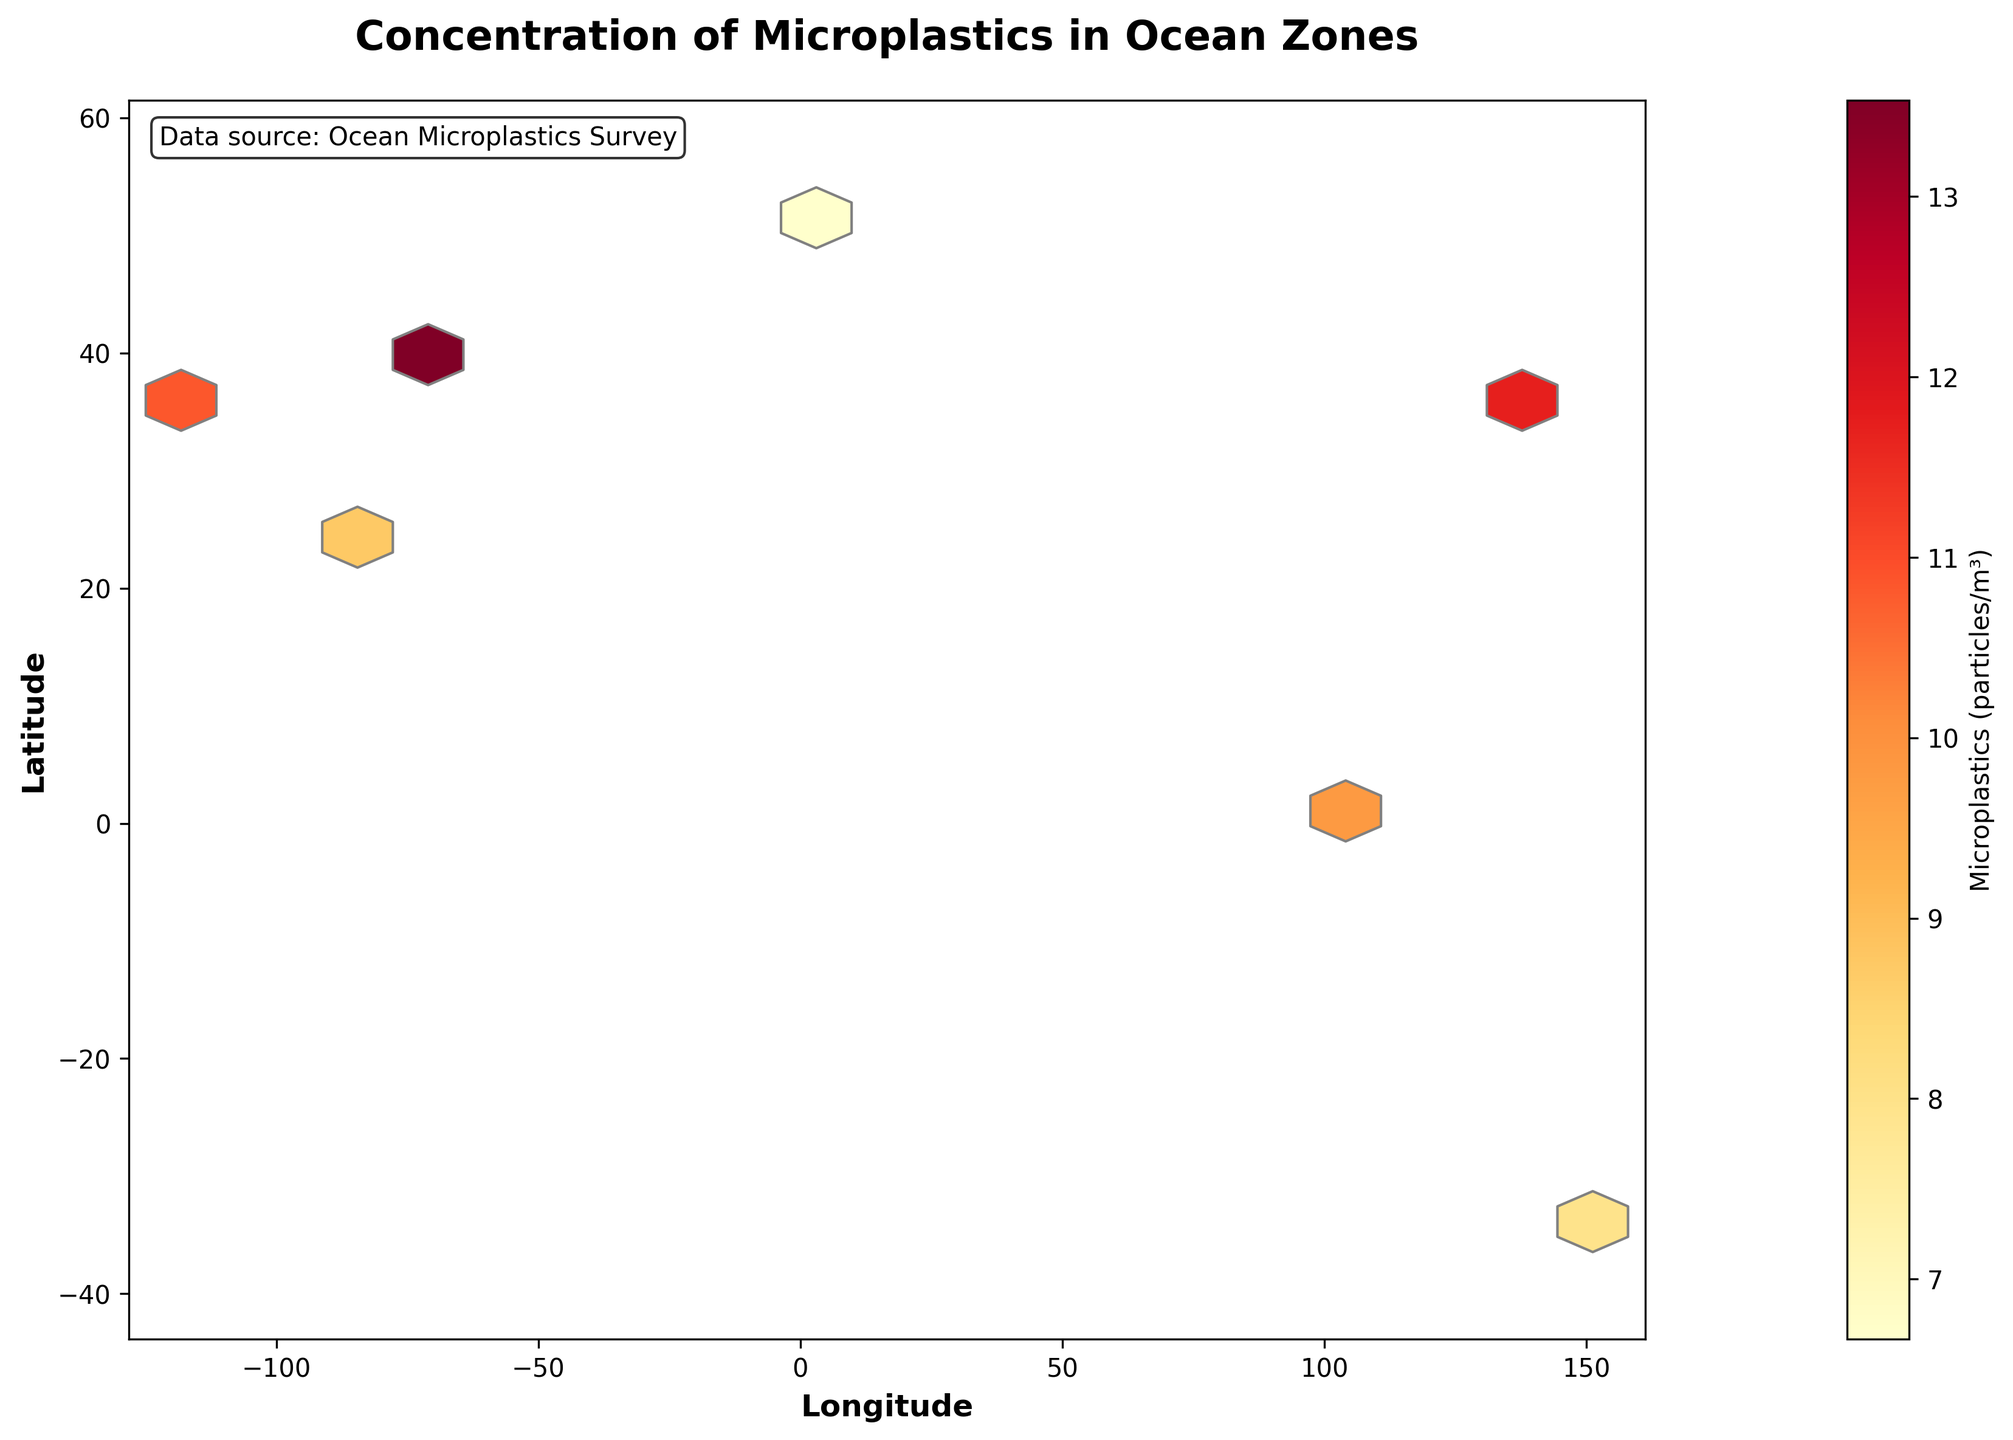What is the title of the figure? The title of the figure is located at the top of the plot. From the visual, we can see the text that describes what the plot represents.
Answer: Concentration of Microplastics in Ocean Zones What do the labels on the x-axis and y-axis represent? The labels on the axes provide contextual information about what is being plotted on each axis. By looking at the plot, we can see the text next to the axes.
Answer: Longitude, Latitude What color indicates the highest concentration of microplastics? The colors in the hexbin plot represent different concentrations of microplastics, with a colorbar legend to aid interpretation. The highest concentration is represented by the color indicated at the upper end of the color gradient on the colorbar.
Answer: Dark Red How do microplastic concentrations vary with depth in the ocean zones? Since depth data is not explicitly plotted but the figure represents averaged or cumulative concentrations, we need to compare the values at different coordinates to sense trends. Generally, higher concentrations at surface vs. depths shown by lower plotted values at deeper coordinates.
Answer: Higher at the surface, lower at deeper depths Which region shows the highest concentration of microplastics? By examining the denser hexagons and referring to the color that represents higher values on the colorbar, the region exhibiting this color indicates the highest concentration.
Answer: Around 40.7128,-74.0060 (New York) Is there any significant difference in microplastic concentration between the Northern and Southern Hemispheres? We compare the density and color of hexagons above and below the equator (0° latitude). Visual inspection of the color intensity indicates concentration differences.
Answer: Yes, higher in the Northern Hemisphere What is the approximate concentration value indicated by the light yellow color in the color gradient? The light yellow color on the colorbar corresponds to a specific value, which can be read by matching the color to the values on the colorbar's scale.
Answer: Around 10 particles/m³ Are there more regions with low or high microplastic concentrations according to the hexbin plot? By observing the quantity and spread of hexagons depicting different concentration ranges, as detailed by the color gradient, we can count the occurrence of each category.
Answer: More regions with low concentrations Is there a noticeable trend in microplastic concentration relative to longitude? By analyzing horizontal patterns in the plot's color gradient and hexagon density, we can determine if there is a consistent increase or decrease across longitudes.
Answer: Higher concentrations at certain longitudes, but not consistent across all values How does the concentration of microplastics in the surface zone compare to the concentration in deeper zones? We need to compare the given data points across all depths and look at the colors representing those on the plot. Summarize observations of these comparisons.
Answer: Generally higher at the surface 